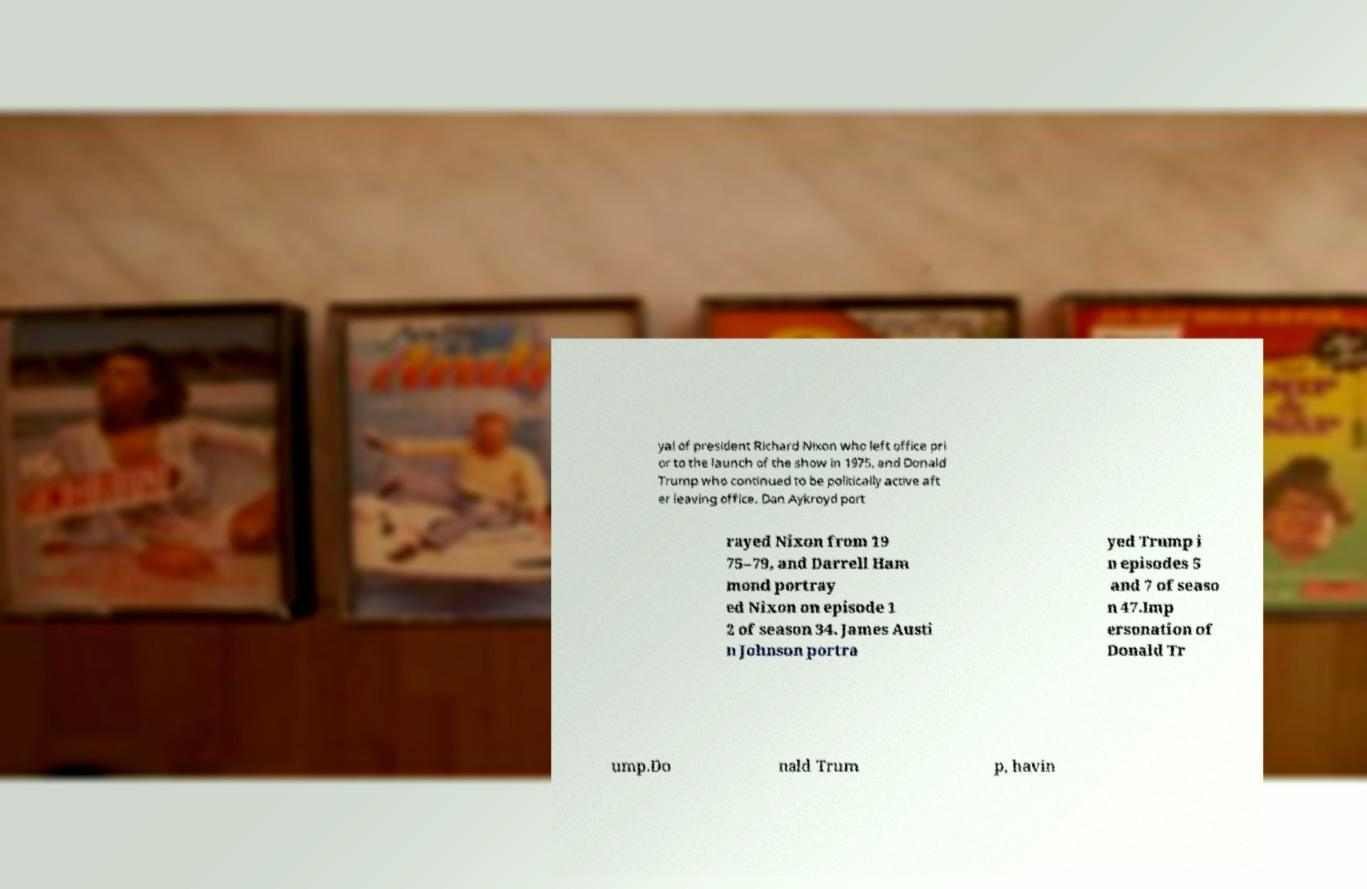Can you accurately transcribe the text from the provided image for me? yal of president Richard Nixon who left office pri or to the launch of the show in 1975, and Donald Trump who continued to be politically active aft er leaving office. Dan Aykroyd port rayed Nixon from 19 75–79, and Darrell Ham mond portray ed Nixon on episode 1 2 of season 34. James Austi n Johnson portra yed Trump i n episodes 5 and 7 of seaso n 47.Imp ersonation of Donald Tr ump.Do nald Trum p, havin 